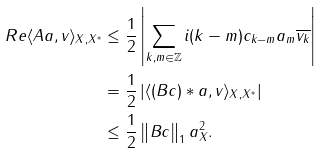<formula> <loc_0><loc_0><loc_500><loc_500>R e \langle A a , v \rangle _ { X , X ^ { \ast } } & \leq \frac { 1 } { 2 } \left | \sum _ { k , m \in \mathbb { Z } } i ( k - m ) c _ { k - m } a _ { m } \overline { v _ { k } } \right | \\ & = \frac { 1 } { 2 } \left | \langle ( B c ) * a , v \rangle _ { X , X ^ { \ast } } \right | \\ & \leq \frac { 1 } { 2 } \left \| B c \right \| _ { 1 } \| a \| _ { X } ^ { 2 } .</formula> 